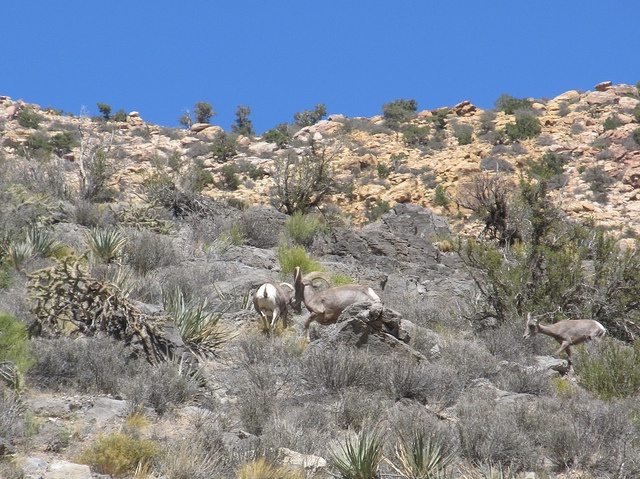Describe the objects in this image and their specific colors. I can see sheep in gray, darkgray, and lightgray tones, sheep in gray, darkgray, and black tones, and sheep in gray, darkgray, and white tones in this image. 